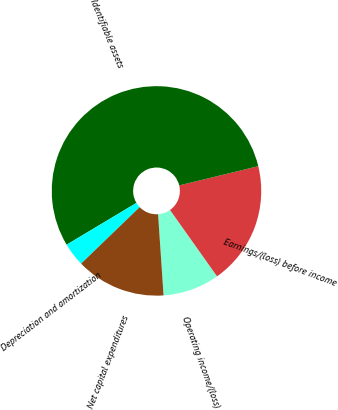Convert chart to OTSL. <chart><loc_0><loc_0><loc_500><loc_500><pie_chart><fcel>Operating income/(loss)<fcel>Earnings/(loss) before income<fcel>Identifiable assets<fcel>Depreciation and amortization<fcel>Net capital expenditures<nl><fcel>8.74%<fcel>18.98%<fcel>54.8%<fcel>3.63%<fcel>13.86%<nl></chart> 